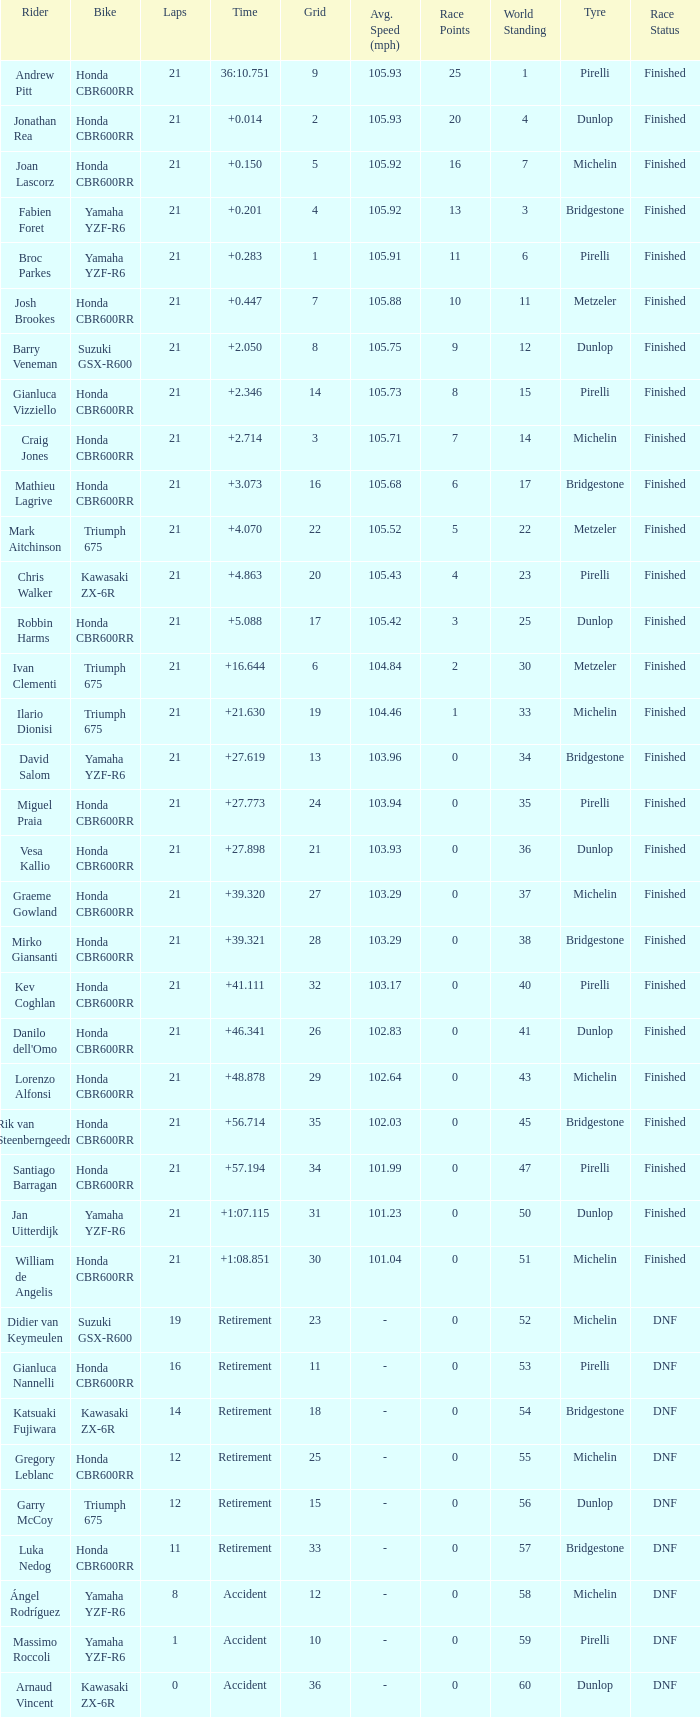What driver had the highest grid position with a time of +0.283? 1.0. 